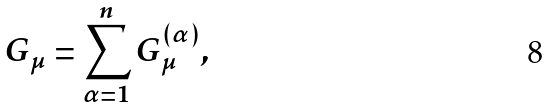Convert formula to latex. <formula><loc_0><loc_0><loc_500><loc_500>G _ { \mu } & = \sum _ { \alpha = 1 } ^ { n } G _ { \mu } ^ { ( \alpha ) } ,</formula> 